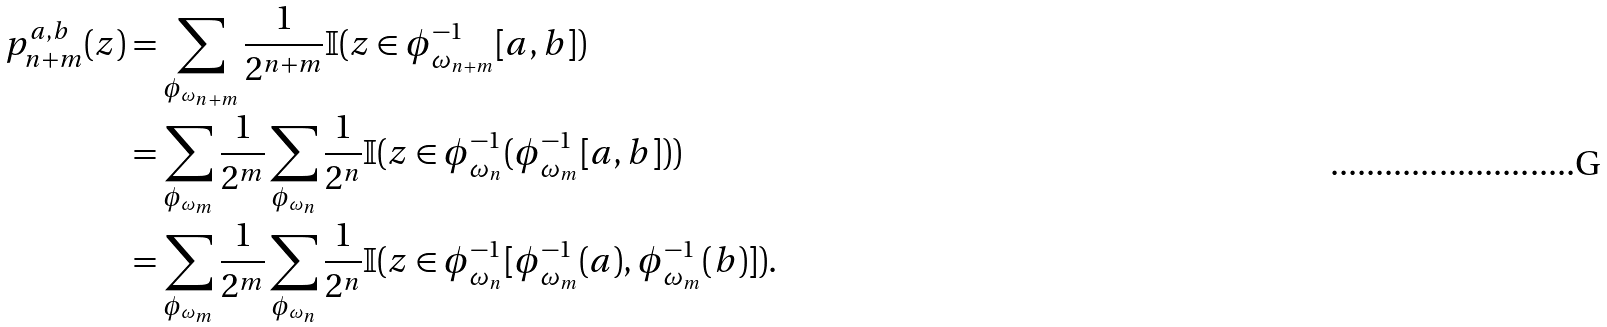Convert formula to latex. <formula><loc_0><loc_0><loc_500><loc_500>p _ { n + m } ^ { a , b } ( z ) & = \sum _ { \phi _ { \omega _ { n + m } } } \frac { 1 } { 2 ^ { n + m } } \mathbb { I } ( z \in \phi _ { \omega _ { n + m } } ^ { - 1 } [ a , b ] ) \\ & = \sum _ { \phi _ { \omega _ { m } } } \frac { 1 } { 2 ^ { m } } \sum _ { \phi _ { \omega _ { n } } } \frac { 1 } { 2 ^ { n } } \mathbb { I } ( z \in \phi _ { \omega _ { n } } ^ { - 1 } ( \phi _ { \omega _ { m } } ^ { - 1 } [ a , b ] ) ) \\ & = \sum _ { \phi _ { \omega _ { m } } } \frac { 1 } { 2 ^ { m } } \sum _ { \phi _ { \omega _ { n } } } \frac { 1 } { 2 ^ { n } } \mathbb { I } ( z \in \phi _ { \omega _ { n } } ^ { - 1 } [ \phi _ { \omega _ { m } } ^ { - 1 } ( a ) , \phi _ { \omega _ { m } } ^ { - 1 } ( b ) ] ) .</formula> 